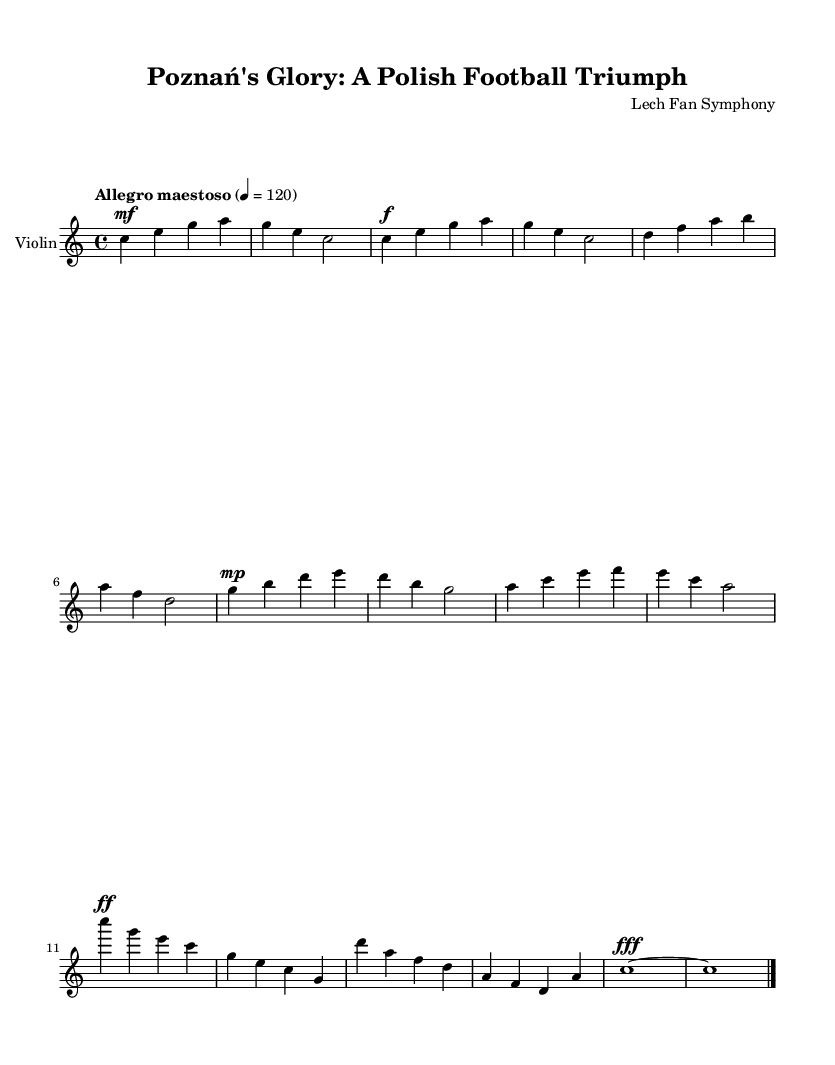What is the key signature of this music? The key signature is specified as "c major" in the global context, indicating it has no sharps or flats.
Answer: C major What is the time signature of this symphony? The time signature is noted as "4/4" in the global section, meaning there are four beats in each measure and the quarter note receives one beat.
Answer: 4/4 What is the tempo marking for this piece? The tempo is indicated as "Allegro maestoso," which generally suggests a fast and majestic pace, with a metronome marking of 120 beats per minute.
Answer: Allegro maestoso How many measures are in the main theme? The main theme is comprised of two measures, identifiable by the sequences presented after the introduction.
Answer: 2 Identify the dynamic marking of the climax section. The climax section features a dynamic marking of "ff," standing for fortissimo, which indicates a very loud playing.
Answer: ff What is the final dynamic indication in the coda? The final measure of the coda ends with a dynamic of "fff," which means even louder than fortissimo, creating an emphatic finish.
Answer: fff Which instrument is primarily featured in this score? The score is specifically for the violin, as indicated in the staff title "Violin."
Answer: Violin 